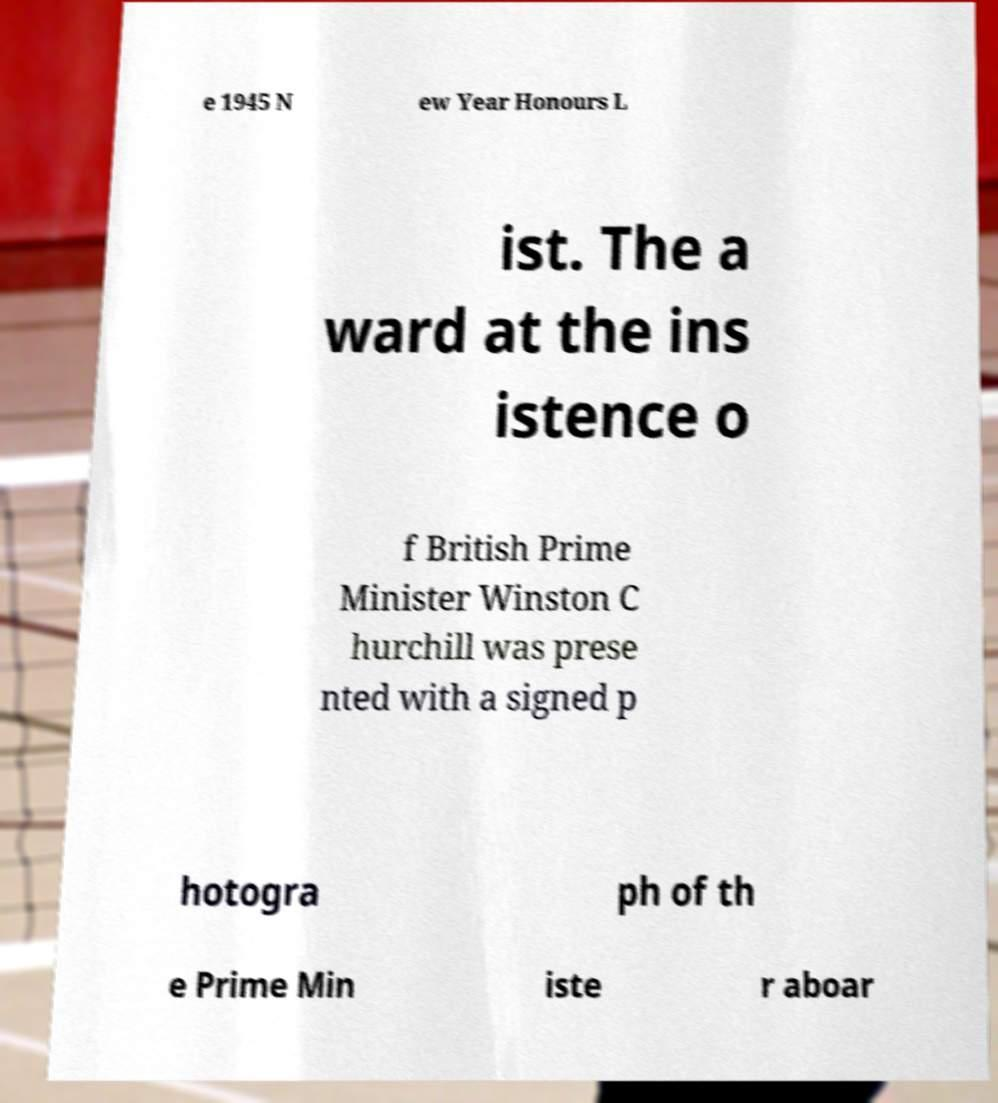Can you accurately transcribe the text from the provided image for me? e 1945 N ew Year Honours L ist. The a ward at the ins istence o f British Prime Minister Winston C hurchill was prese nted with a signed p hotogra ph of th e Prime Min iste r aboar 